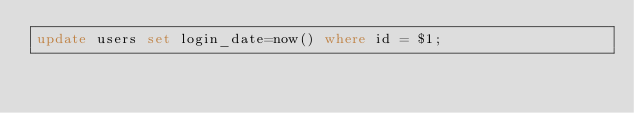<code> <loc_0><loc_0><loc_500><loc_500><_SQL_>update users set login_date=now() where id = $1;</code> 